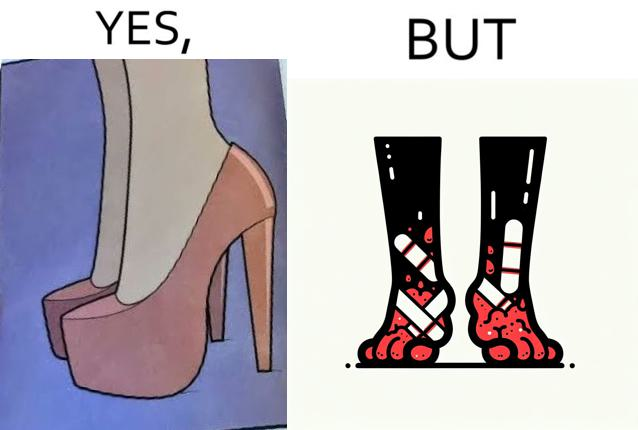What makes this image funny or satirical? The images are funny since they show how the prettiest footwears like high heels, end up causing a lot of physical discomfort to the user, all in the name fashion 